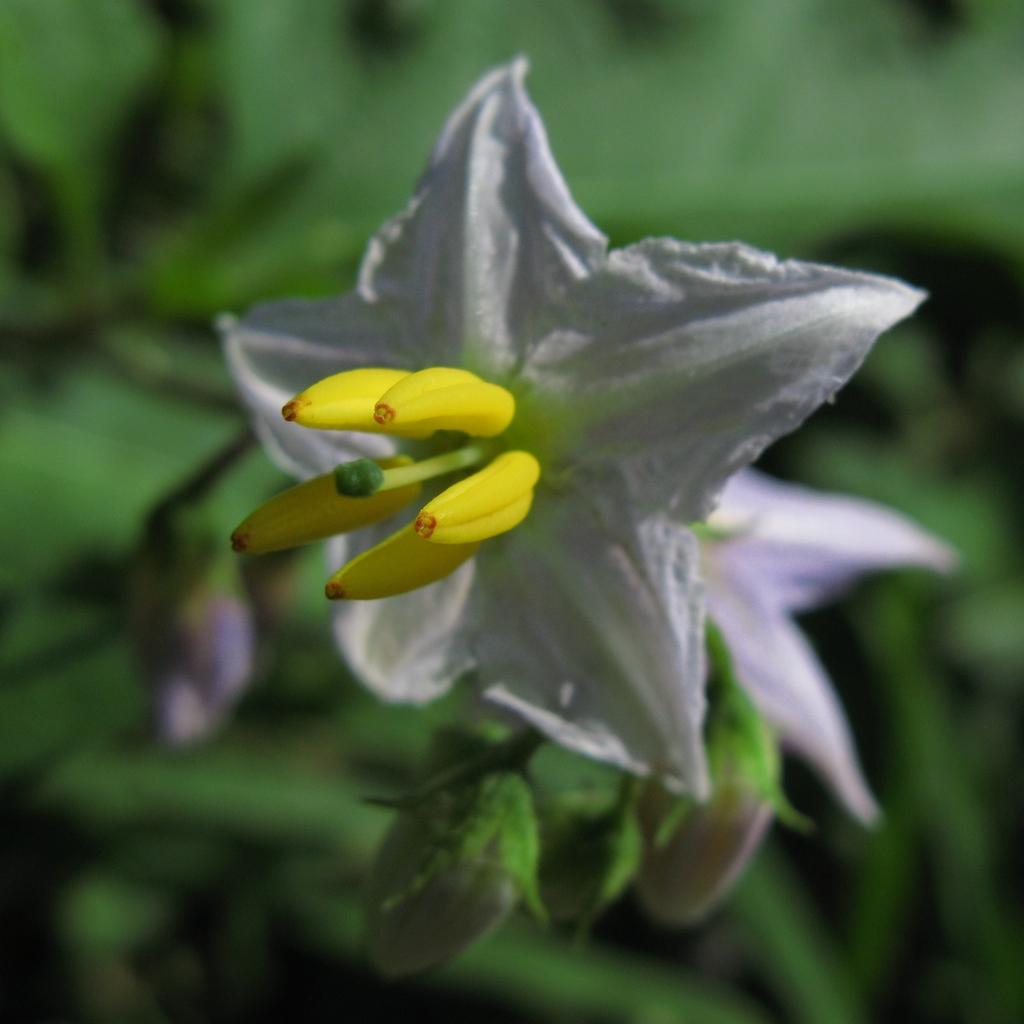What type of plant is visible in the image? There is a flower on a plant in the image. Can you describe the flower in more detail? Unfortunately, the image does not provide enough detail to describe the flower further. What type of liquid can be seen flowing through the harbor in the image? There is no harbor or liquid present in the image; it only features a flower on a plant. 